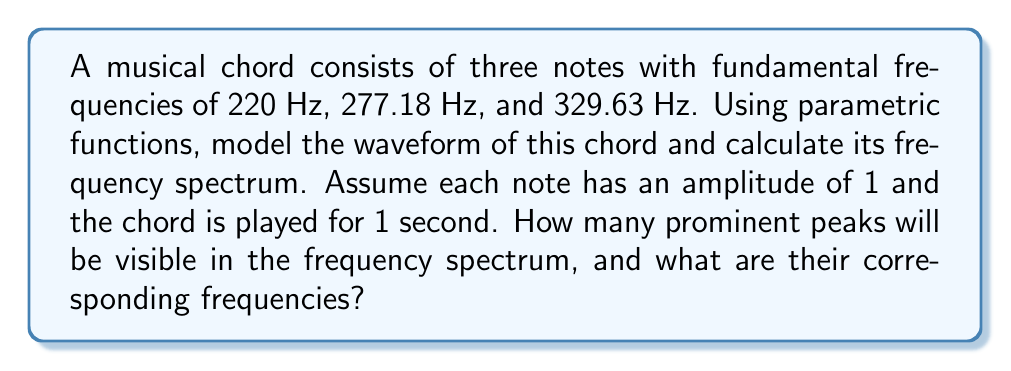Teach me how to tackle this problem. To solve this problem, we'll follow these steps:

1) First, let's model each note as a sine wave using parametric functions:

   $$x_1(t) = \sin(2\pi \cdot 220t)$$
   $$x_2(t) = \sin(2\pi \cdot 277.18t)$$
   $$x_3(t) = \sin(2\pi \cdot 329.63t)$$

2) The combined waveform of the chord is the sum of these individual waves:

   $$x(t) = x_1(t) + x_2(t) + x_3(t)$$

3) To find the frequency spectrum, we need to perform a Fourier transform on $x(t)$. In practice, this would be done using a Fast Fourier Transform (FFT) algorithm. The result would show the amplitude of each frequency component.

4) The frequency spectrum will show prominent peaks at the fundamental frequencies of each note:
   - 220 Hz (A3)
   - 277.18 Hz (C#4)
   - 329.63 Hz (E4)

5) In addition to these fundamental frequencies, the spectrum will also show peaks at the harmonic frequencies for each note. Harmonics occur at integer multiples of the fundamental frequency. However, the amplitude of these harmonics typically decreases as the frequency increases.

6) For a 1-second sample, the frequency resolution of the spectrum will be 1 Hz. This means we can clearly distinguish the fundamental frequencies of our three notes.

7) While there will be many smaller peaks due to harmonics, the three most prominent peaks will correspond to the fundamental frequencies of the three notes in the chord.

Therefore, there will be 3 prominent peaks in the frequency spectrum, corresponding to the frequencies 220 Hz, 277.18 Hz, and 329.63 Hz.
Answer: The frequency spectrum will show 3 prominent peaks at 220 Hz, 277.18 Hz, and 329.63 Hz. 